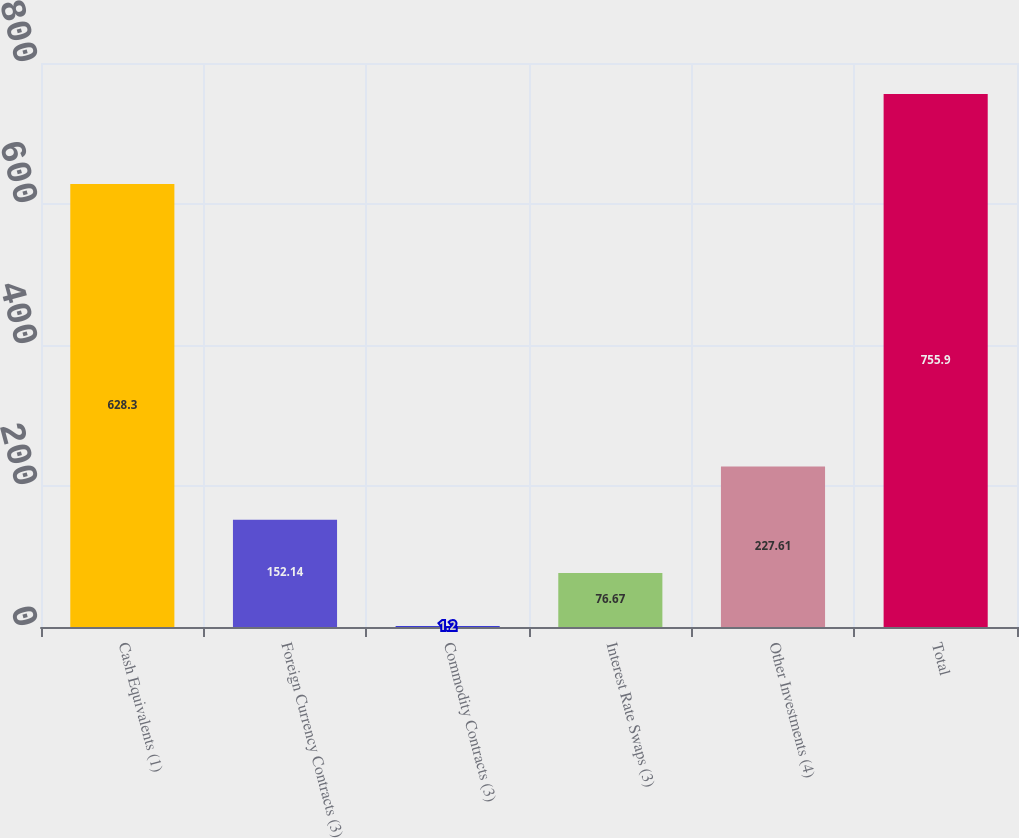<chart> <loc_0><loc_0><loc_500><loc_500><bar_chart><fcel>Cash Equivalents (1)<fcel>Foreign Currency Contracts (3)<fcel>Commodity Contracts (3)<fcel>Interest Rate Swaps (3)<fcel>Other Investments (4)<fcel>Total<nl><fcel>628.3<fcel>152.14<fcel>1.2<fcel>76.67<fcel>227.61<fcel>755.9<nl></chart> 